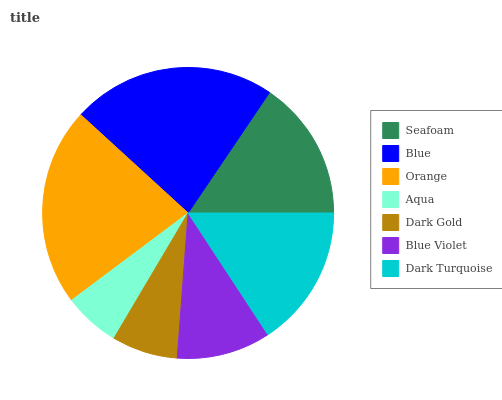Is Aqua the minimum?
Answer yes or no. Yes. Is Blue the maximum?
Answer yes or no. Yes. Is Orange the minimum?
Answer yes or no. No. Is Orange the maximum?
Answer yes or no. No. Is Blue greater than Orange?
Answer yes or no. Yes. Is Orange less than Blue?
Answer yes or no. Yes. Is Orange greater than Blue?
Answer yes or no. No. Is Blue less than Orange?
Answer yes or no. No. Is Seafoam the high median?
Answer yes or no. Yes. Is Seafoam the low median?
Answer yes or no. Yes. Is Dark Gold the high median?
Answer yes or no. No. Is Blue the low median?
Answer yes or no. No. 